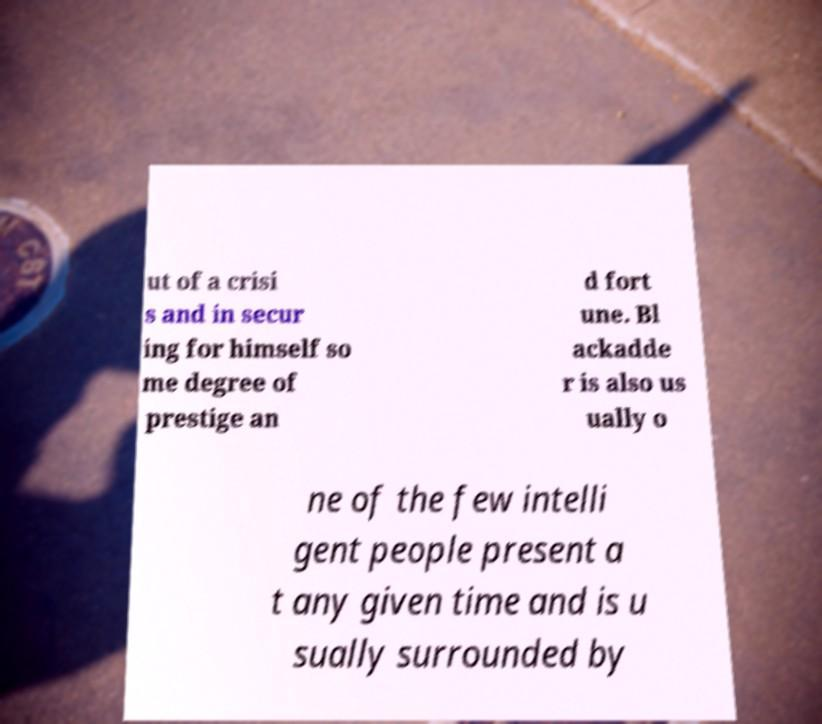Can you accurately transcribe the text from the provided image for me? ut of a crisi s and in secur ing for himself so me degree of prestige an d fort une. Bl ackadde r is also us ually o ne of the few intelli gent people present a t any given time and is u sually surrounded by 